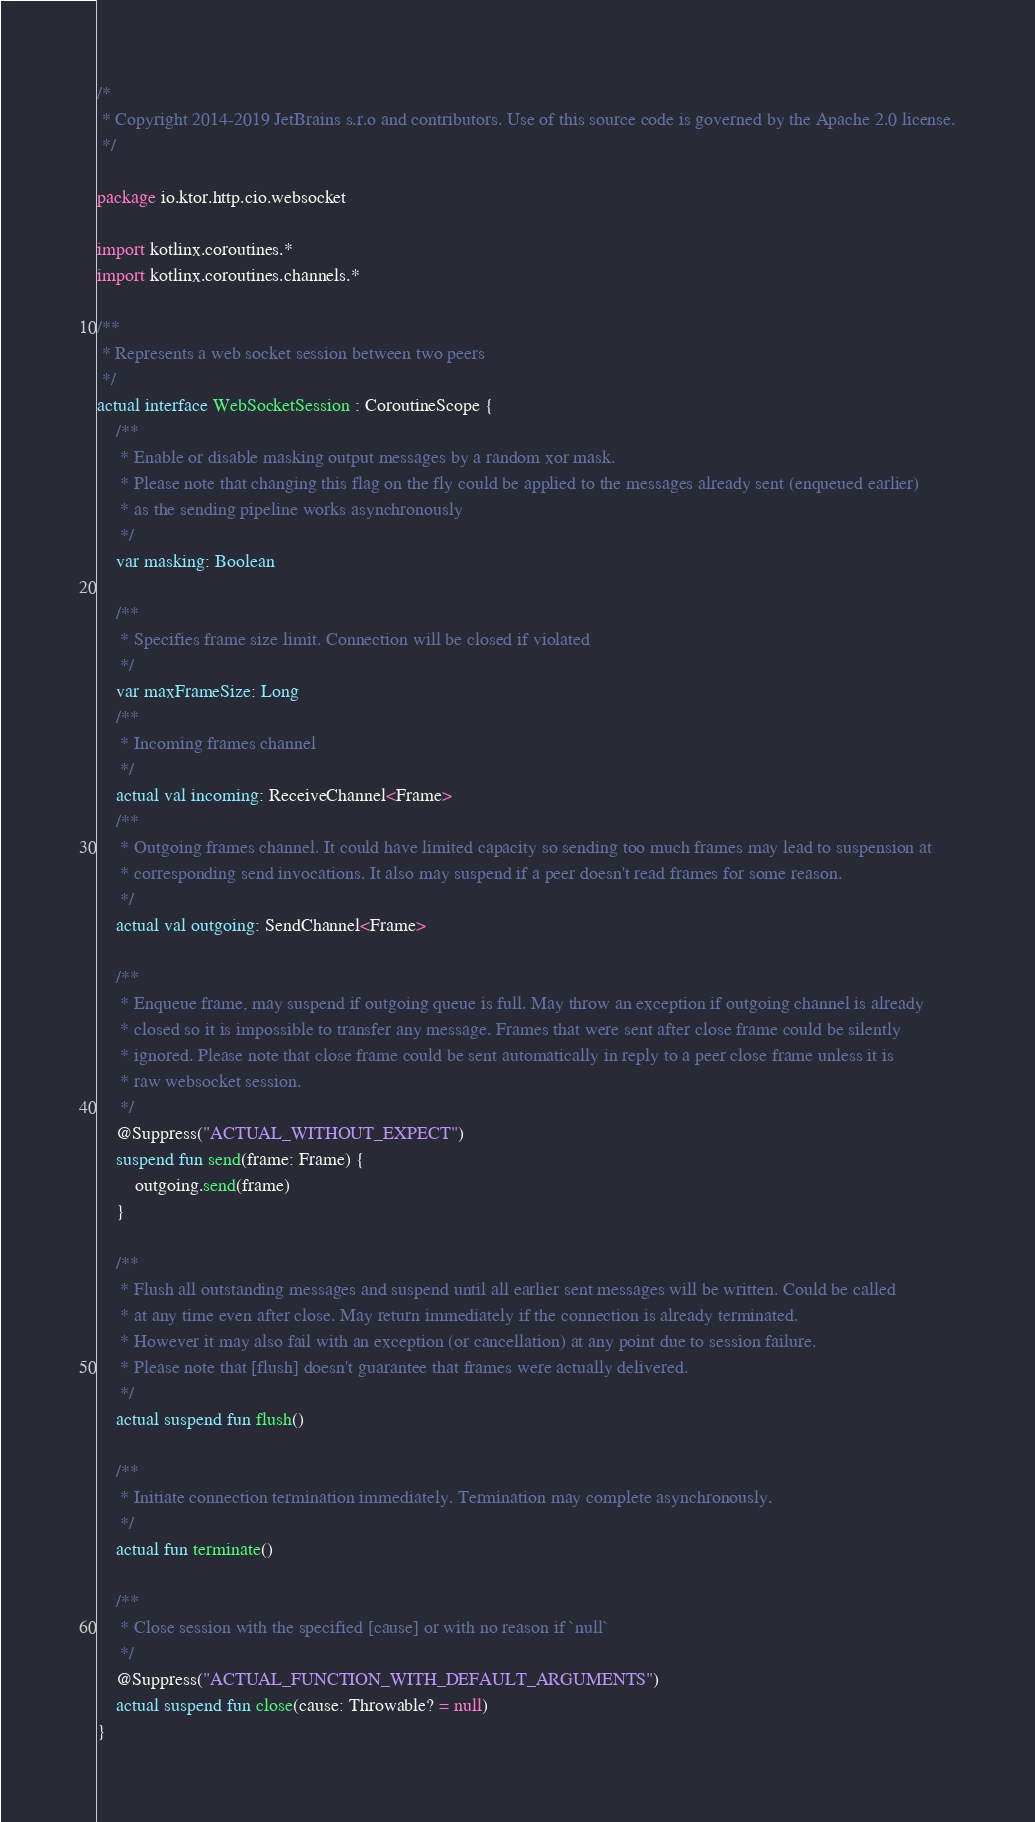<code> <loc_0><loc_0><loc_500><loc_500><_Kotlin_>/*
 * Copyright 2014-2019 JetBrains s.r.o and contributors. Use of this source code is governed by the Apache 2.0 license.
 */

package io.ktor.http.cio.websocket

import kotlinx.coroutines.*
import kotlinx.coroutines.channels.*

/**
 * Represents a web socket session between two peers
 */
actual interface WebSocketSession : CoroutineScope {
    /**
     * Enable or disable masking output messages by a random xor mask.
     * Please note that changing this flag on the fly could be applied to the messages already sent (enqueued earlier)
     * as the sending pipeline works asynchronously
     */
    var masking: Boolean

    /**
     * Specifies frame size limit. Connection will be closed if violated
     */
    var maxFrameSize: Long
    /**
     * Incoming frames channel
     */
    actual val incoming: ReceiveChannel<Frame>
    /**
     * Outgoing frames channel. It could have limited capacity so sending too much frames may lead to suspension at
     * corresponding send invocations. It also may suspend if a peer doesn't read frames for some reason.
     */
    actual val outgoing: SendChannel<Frame>

    /**
     * Enqueue frame, may suspend if outgoing queue is full. May throw an exception if outgoing channel is already
     * closed so it is impossible to transfer any message. Frames that were sent after close frame could be silently
     * ignored. Please note that close frame could be sent automatically in reply to a peer close frame unless it is
     * raw websocket session.
     */
    @Suppress("ACTUAL_WITHOUT_EXPECT")
    suspend fun send(frame: Frame) {
        outgoing.send(frame)
    }

    /**
     * Flush all outstanding messages and suspend until all earlier sent messages will be written. Could be called
     * at any time even after close. May return immediately if the connection is already terminated.
     * However it may also fail with an exception (or cancellation) at any point due to session failure.
     * Please note that [flush] doesn't guarantee that frames were actually delivered.
     */
    actual suspend fun flush()

    /**
     * Initiate connection termination immediately. Termination may complete asynchronously.
     */
    actual fun terminate()

    /**
     * Close session with the specified [cause] or with no reason if `null`
     */
    @Suppress("ACTUAL_FUNCTION_WITH_DEFAULT_ARGUMENTS")
    actual suspend fun close(cause: Throwable? = null)
}
</code> 